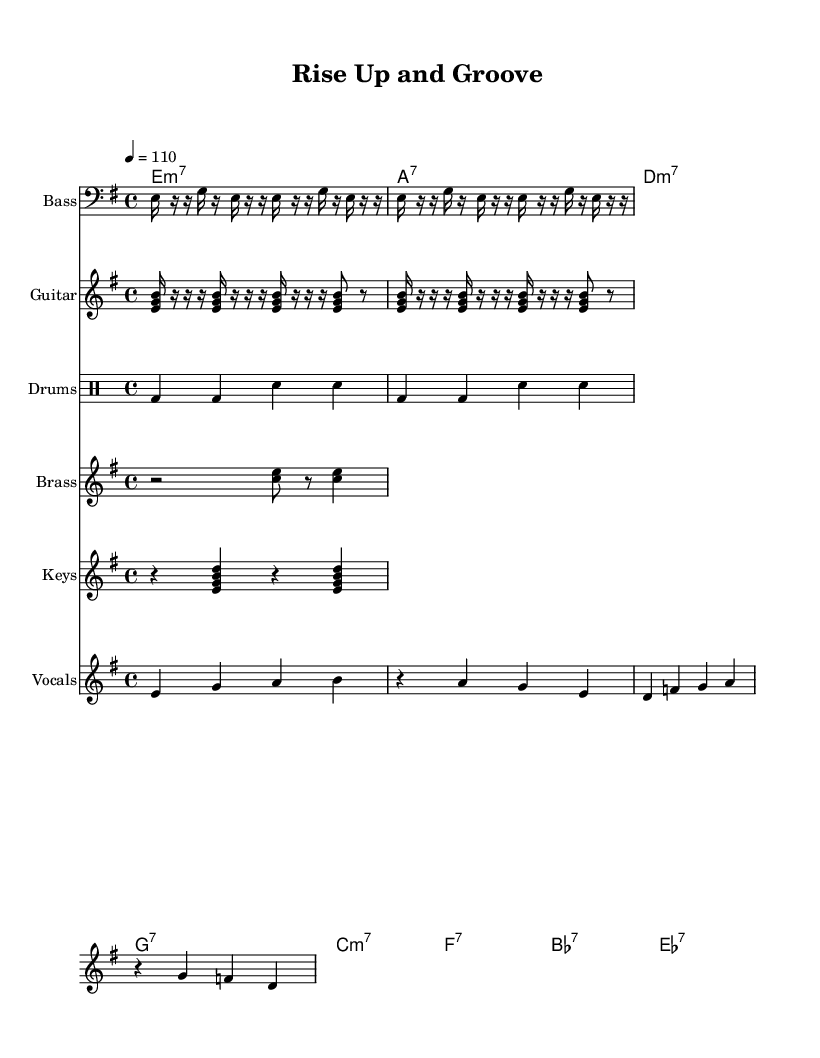What is the key signature of this music? The key signature indicates that the piece is in E minor, as there is one sharp (F#) present in the scale. This can be inferred from the key indicated at the beginning of the score.
Answer: E minor What is the time signature of this music? The time signature shows that the piece is in 4/4 time, which means there are four beats per measure and the quarter note receives one beat. This is clearly noted in the section that specifies the meter.
Answer: 4/4 What is the tempo marking of this piece? The tempo is indicated to be 110 beats per minute, which is shown by the marking near the beginning of the score. This indicates the speed at which the music should be played.
Answer: 110 How many measures are in the vocal melody section? By analyzing the vocal melody written out in the score, there are a total of four measures that contain a combination of notes and rests. This can be counted by looking at the vertical lines which denote each measure.
Answer: 4 What instruments are featured in this score? The score features several instruments, namely the Bass, Guitar, Drums, Brass, Keys, and Vocals. This can be seen in the individual staff names designated for each part at the beginning of each section.
Answer: Bass, Guitar, Drums, Brass, Keys, Vocals What kind of rhythmic pattern can be observed in the drum section? The drum pattern consists of a simple alternating kick drum (bd) and snare drum (sn) rhythm repeated across measures, illustrating a typical funk style that emphasizes the backbeat. This can be identified within the drum staff where the rhythmic notation is displayed.
Answer: Alternating kick and snare What chord type is indicated for the first chord in the score? The first chord in the chord names section specifies E minor 7 (e:m7). This information is located in the ChordNames staff where the chord symbols are notated.
Answer: E minor 7 